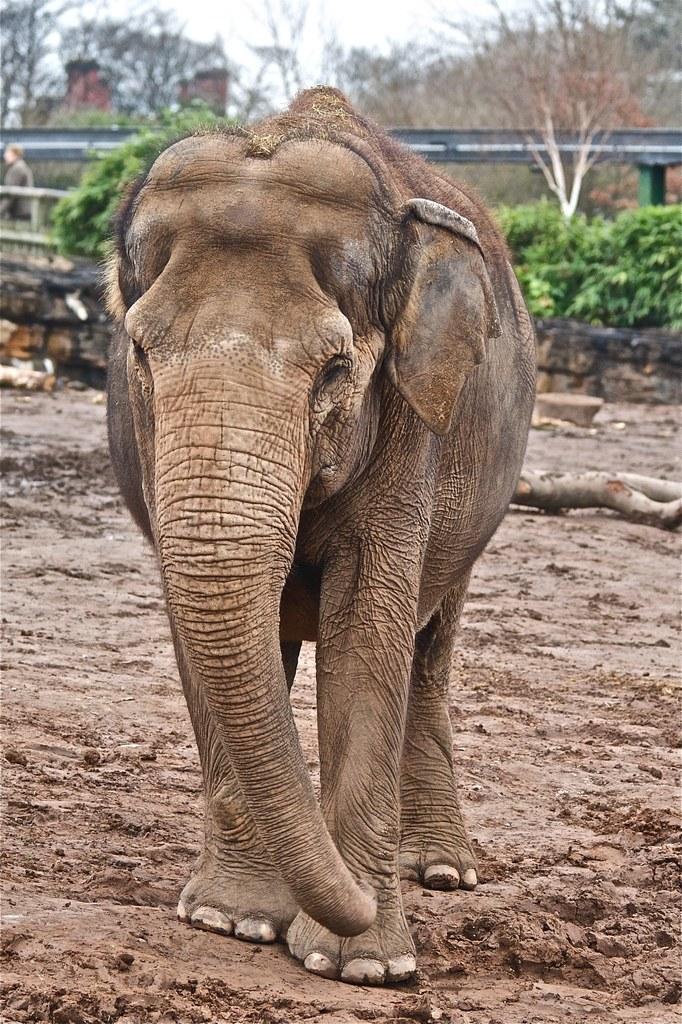Could you give a brief overview of what you see in this image? This picture is clicked outside. In the center we can see an elephant standing on the sand. In the background we can see the green leaves and some other objects and we can see the sky, trees and some metal objects. 